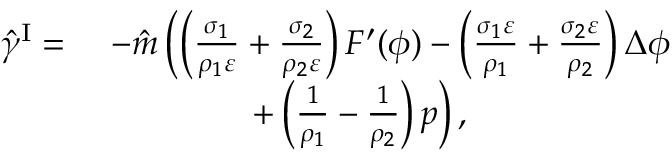<formula> <loc_0><loc_0><loc_500><loc_500>\begin{array} { r l } { \hat { \gamma } ^ { I } = } & { - \hat { m } \left ( \left ( \frac { \sigma _ { 1 } } { \rho _ { 1 } \varepsilon } + \frac { \sigma _ { 2 } } { \rho _ { 2 } \varepsilon } \right ) F ^ { \prime } ( \phi ) - \left ( \frac { \sigma _ { 1 } \varepsilon } { \rho _ { 1 } } + \frac { \sigma _ { 2 } \varepsilon } { \rho _ { 2 } } \right ) \Delta \phi } \\ & { \quad + \left ( \frac { 1 } { \rho _ { 1 } } - \frac { 1 } { \rho _ { 2 } } \right ) p \right ) , } \end{array}</formula> 